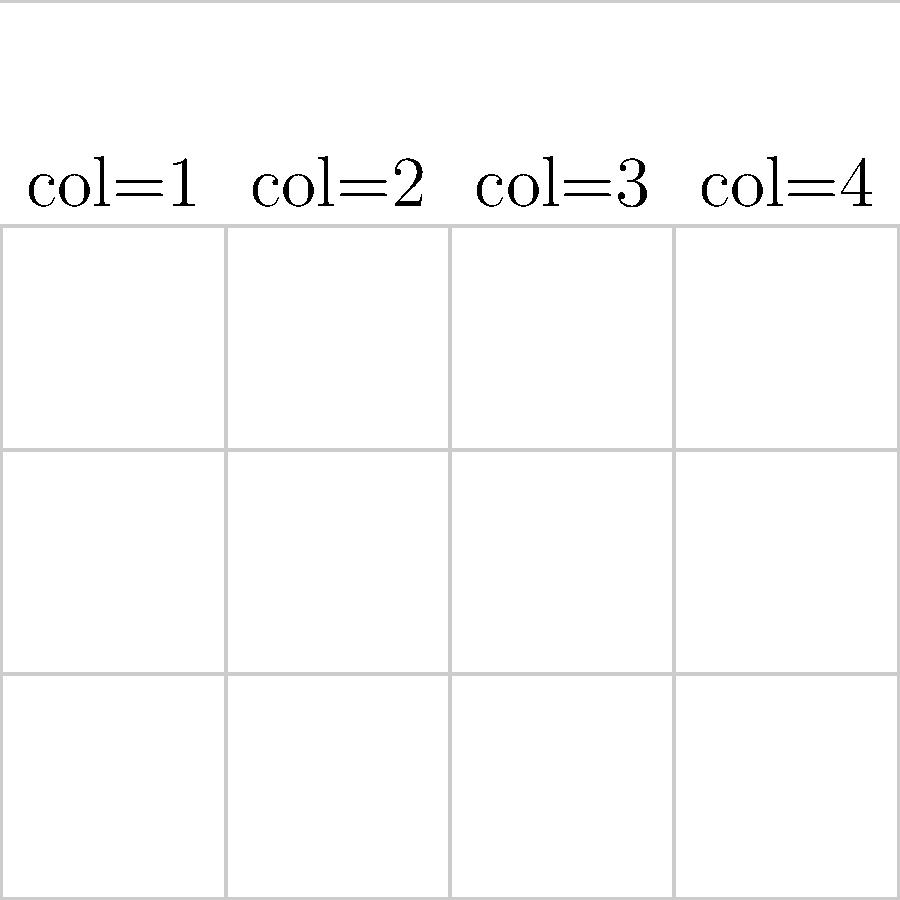In the given Angular Material grid list layout, what attribute should be applied to tile A to achieve its current size and position? To determine the correct attribute for tile A, let's analyze the grid layout step-by-step:

1. The grid has 4 columns and 3 rows.
2. Tile A spans 2 columns (from col 1 to col 2) and 2 rows (from row 1 to row 2).
3. In Angular Material's grid list, we can use the `colspan` attribute to define how many columns a tile should span.
4. We can use the `rowspan` attribute to define how many rows a tile should span.
5. For tile A, we need to span 2 columns and 2 rows.
6. The `colspan` attribute should be set to 2 to span 2 columns.
7. The `rowspan` attribute should be set to 2 to span 2 rows.

Therefore, to achieve the size and position of tile A, we need to apply both `colspan="2"` and `rowspan="2"` attributes to the `mat-grid-tile` element.
Answer: colspan="2" rowspan="2" 